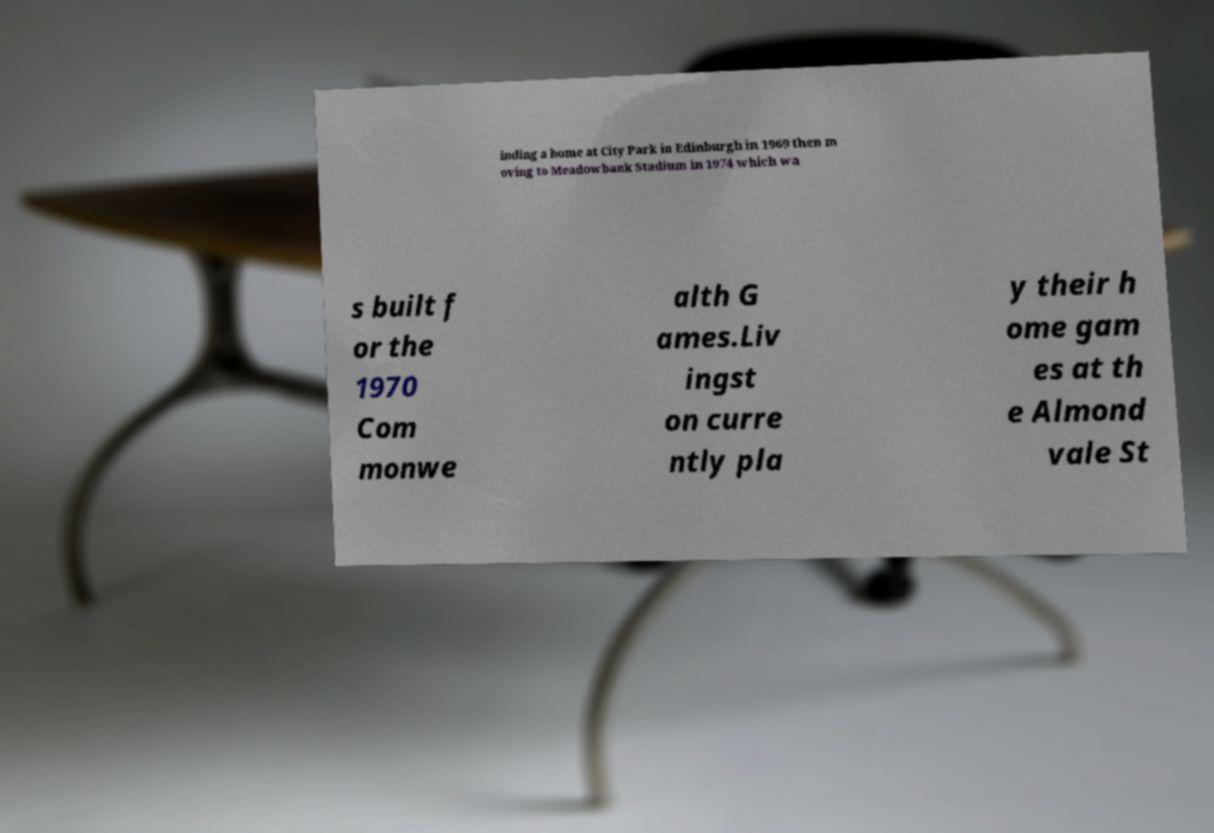Can you read and provide the text displayed in the image?This photo seems to have some interesting text. Can you extract and type it out for me? inding a home at City Park in Edinburgh in 1969 then m oving to Meadowbank Stadium in 1974 which wa s built f or the 1970 Com monwe alth G ames.Liv ingst on curre ntly pla y their h ome gam es at th e Almond vale St 